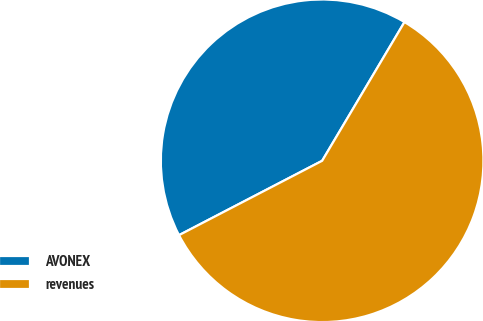<chart> <loc_0><loc_0><loc_500><loc_500><pie_chart><fcel>AVONEX<fcel>revenues<nl><fcel>41.15%<fcel>58.85%<nl></chart> 